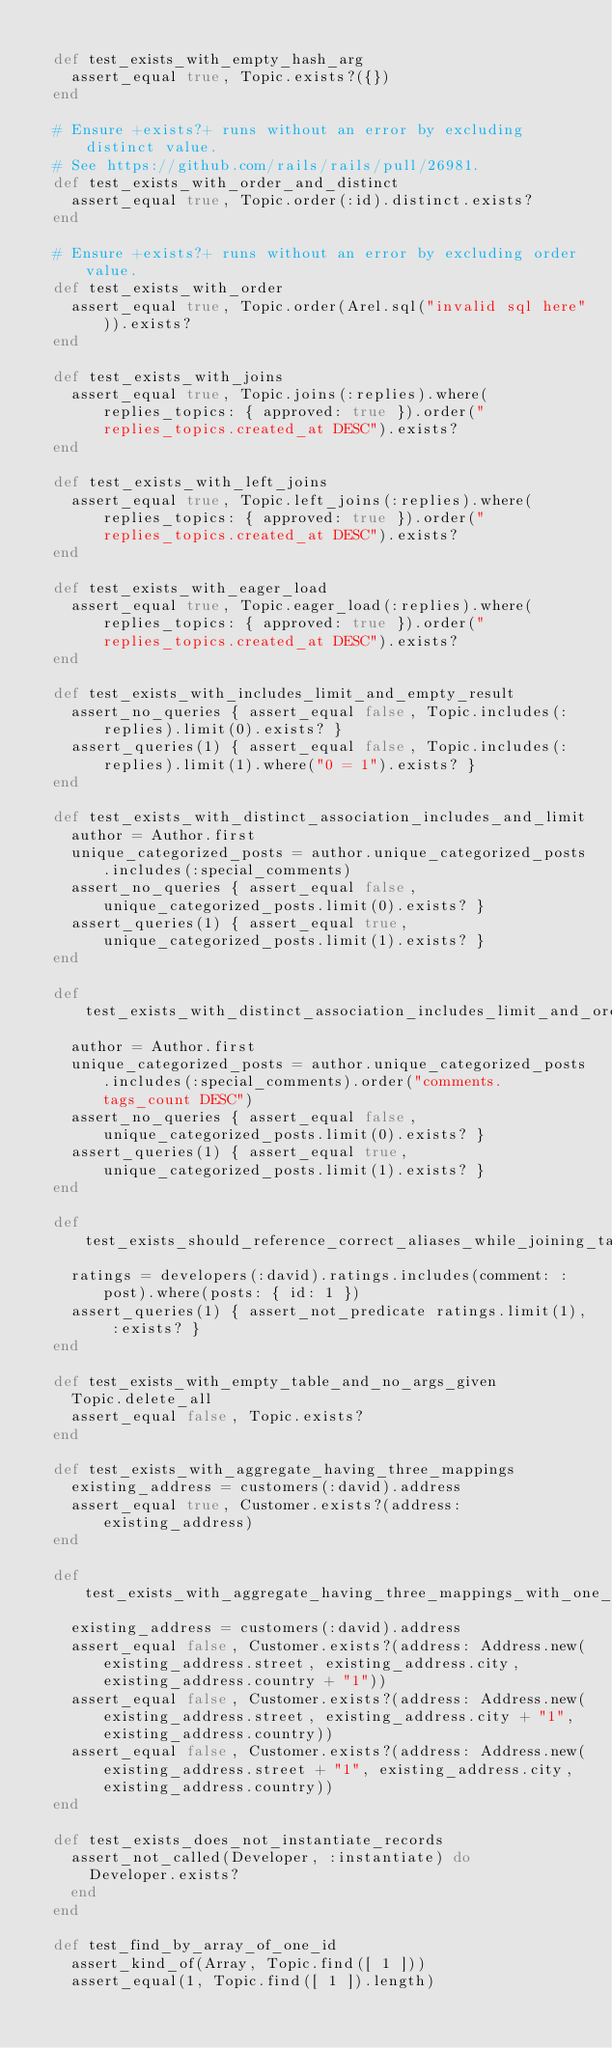<code> <loc_0><loc_0><loc_500><loc_500><_Ruby_>
  def test_exists_with_empty_hash_arg
    assert_equal true, Topic.exists?({})
  end

  # Ensure +exists?+ runs without an error by excluding distinct value.
  # See https://github.com/rails/rails/pull/26981.
  def test_exists_with_order_and_distinct
    assert_equal true, Topic.order(:id).distinct.exists?
  end

  # Ensure +exists?+ runs without an error by excluding order value.
  def test_exists_with_order
    assert_equal true, Topic.order(Arel.sql("invalid sql here")).exists?
  end

  def test_exists_with_joins
    assert_equal true, Topic.joins(:replies).where(replies_topics: { approved: true }).order("replies_topics.created_at DESC").exists?
  end

  def test_exists_with_left_joins
    assert_equal true, Topic.left_joins(:replies).where(replies_topics: { approved: true }).order("replies_topics.created_at DESC").exists?
  end

  def test_exists_with_eager_load
    assert_equal true, Topic.eager_load(:replies).where(replies_topics: { approved: true }).order("replies_topics.created_at DESC").exists?
  end

  def test_exists_with_includes_limit_and_empty_result
    assert_no_queries { assert_equal false, Topic.includes(:replies).limit(0).exists? }
    assert_queries(1) { assert_equal false, Topic.includes(:replies).limit(1).where("0 = 1").exists? }
  end

  def test_exists_with_distinct_association_includes_and_limit
    author = Author.first
    unique_categorized_posts = author.unique_categorized_posts.includes(:special_comments)
    assert_no_queries { assert_equal false, unique_categorized_posts.limit(0).exists? }
    assert_queries(1) { assert_equal true, unique_categorized_posts.limit(1).exists? }
  end

  def test_exists_with_distinct_association_includes_limit_and_order
    author = Author.first
    unique_categorized_posts = author.unique_categorized_posts.includes(:special_comments).order("comments.tags_count DESC")
    assert_no_queries { assert_equal false, unique_categorized_posts.limit(0).exists? }
    assert_queries(1) { assert_equal true, unique_categorized_posts.limit(1).exists? }
  end

  def test_exists_should_reference_correct_aliases_while_joining_tables_of_has_many_through_association
    ratings = developers(:david).ratings.includes(comment: :post).where(posts: { id: 1 })
    assert_queries(1) { assert_not_predicate ratings.limit(1), :exists? }
  end

  def test_exists_with_empty_table_and_no_args_given
    Topic.delete_all
    assert_equal false, Topic.exists?
  end

  def test_exists_with_aggregate_having_three_mappings
    existing_address = customers(:david).address
    assert_equal true, Customer.exists?(address: existing_address)
  end

  def test_exists_with_aggregate_having_three_mappings_with_one_difference
    existing_address = customers(:david).address
    assert_equal false, Customer.exists?(address: Address.new(existing_address.street, existing_address.city, existing_address.country + "1"))
    assert_equal false, Customer.exists?(address: Address.new(existing_address.street, existing_address.city + "1", existing_address.country))
    assert_equal false, Customer.exists?(address: Address.new(existing_address.street + "1", existing_address.city, existing_address.country))
  end

  def test_exists_does_not_instantiate_records
    assert_not_called(Developer, :instantiate) do
      Developer.exists?
    end
  end

  def test_find_by_array_of_one_id
    assert_kind_of(Array, Topic.find([ 1 ]))
    assert_equal(1, Topic.find([ 1 ]).length)</code> 